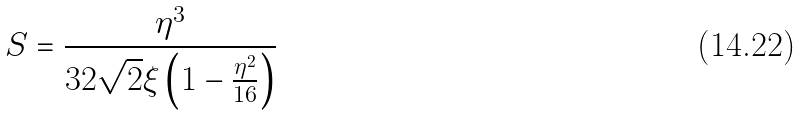<formula> <loc_0><loc_0><loc_500><loc_500>S = \frac { \eta ^ { 3 } } { { 3 2 \sqrt { 2 } \xi \left ( { 1 - \frac { \eta ^ { 2 } } { 1 6 } } \right ) } }</formula> 